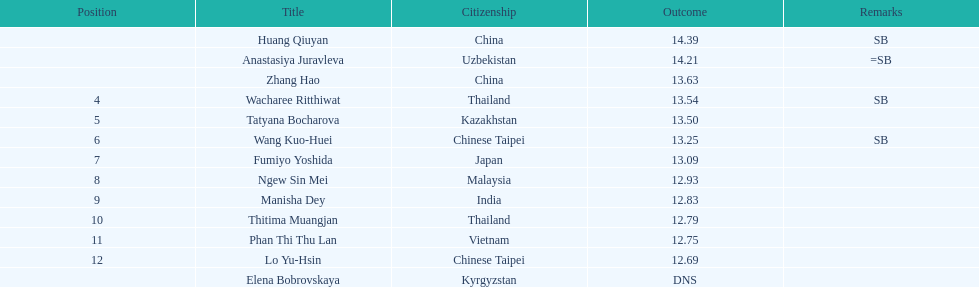What is the number of different nationalities represented by the top 5 athletes? 4. 